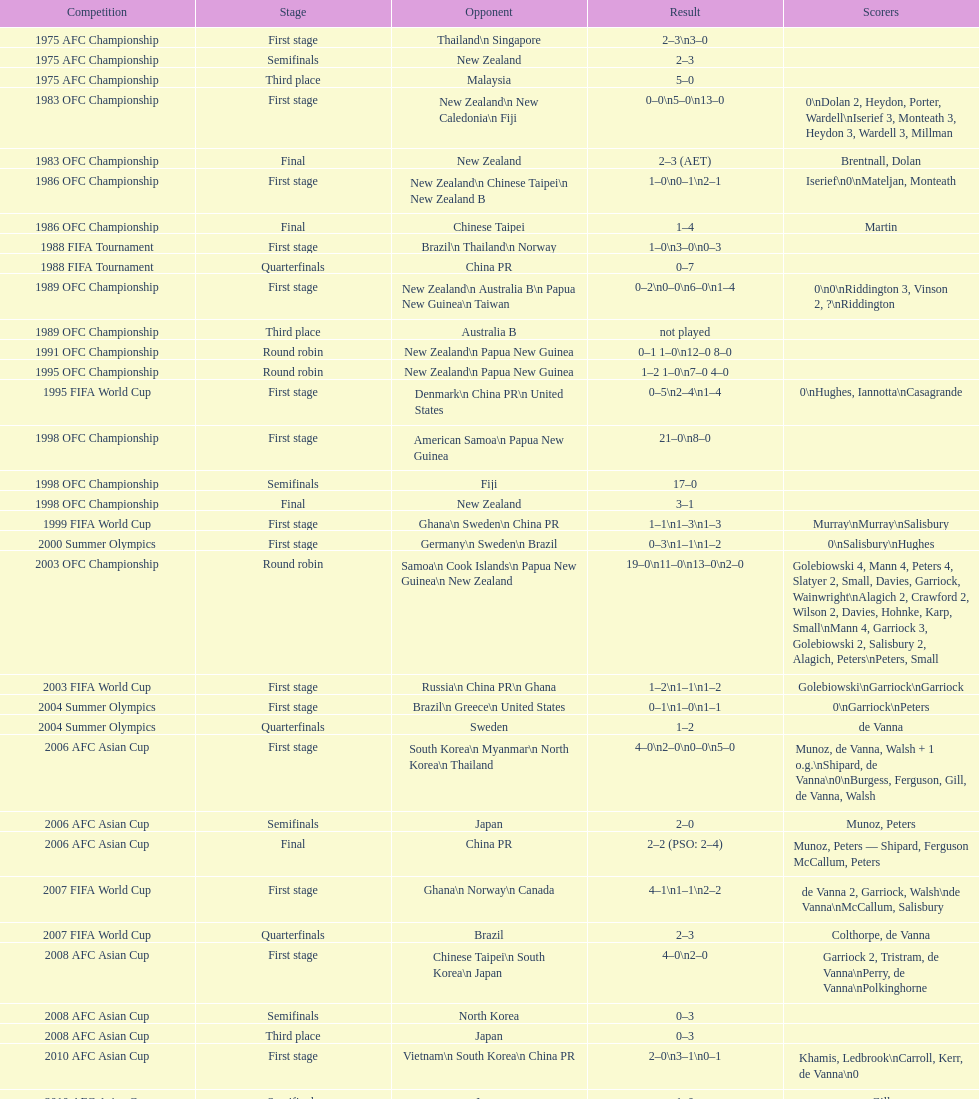What is the overall amount of contests? 21. Could you parse the entire table? {'header': ['Competition', 'Stage', 'Opponent', 'Result', 'Scorers'], 'rows': [['1975 AFC Championship', 'First stage', 'Thailand\\n\xa0Singapore', '2–3\\n3–0', ''], ['1975 AFC Championship', 'Semifinals', 'New Zealand', '2–3', ''], ['1975 AFC Championship', 'Third place', 'Malaysia', '5–0', ''], ['1983 OFC Championship', 'First stage', 'New Zealand\\n\xa0New Caledonia\\n\xa0Fiji', '0–0\\n5–0\\n13–0', '0\\nDolan 2, Heydon, Porter, Wardell\\nIserief 3, Monteath 3, Heydon 3, Wardell 3, Millman'], ['1983 OFC Championship', 'Final', 'New Zealand', '2–3 (AET)', 'Brentnall, Dolan'], ['1986 OFC Championship', 'First stage', 'New Zealand\\n\xa0Chinese Taipei\\n New Zealand B', '1–0\\n0–1\\n2–1', 'Iserief\\n0\\nMateljan, Monteath'], ['1986 OFC Championship', 'Final', 'Chinese Taipei', '1–4', 'Martin'], ['1988 FIFA Tournament', 'First stage', 'Brazil\\n\xa0Thailand\\n\xa0Norway', '1–0\\n3–0\\n0–3', ''], ['1988 FIFA Tournament', 'Quarterfinals', 'China PR', '0–7', ''], ['1989 OFC Championship', 'First stage', 'New Zealand\\n Australia B\\n\xa0Papua New Guinea\\n\xa0Taiwan', '0–2\\n0–0\\n6–0\\n1–4', '0\\n0\\nRiddington 3, Vinson 2,\xa0?\\nRiddington'], ['1989 OFC Championship', 'Third place', 'Australia B', 'not played', ''], ['1991 OFC Championship', 'Round robin', 'New Zealand\\n\xa0Papua New Guinea', '0–1 1–0\\n12–0 8–0', ''], ['1995 OFC Championship', 'Round robin', 'New Zealand\\n\xa0Papua New Guinea', '1–2 1–0\\n7–0 4–0', ''], ['1995 FIFA World Cup', 'First stage', 'Denmark\\n\xa0China PR\\n\xa0United States', '0–5\\n2–4\\n1–4', '0\\nHughes, Iannotta\\nCasagrande'], ['1998 OFC Championship', 'First stage', 'American Samoa\\n\xa0Papua New Guinea', '21–0\\n8–0', ''], ['1998 OFC Championship', 'Semifinals', 'Fiji', '17–0', ''], ['1998 OFC Championship', 'Final', 'New Zealand', '3–1', ''], ['1999 FIFA World Cup', 'First stage', 'Ghana\\n\xa0Sweden\\n\xa0China PR', '1–1\\n1–3\\n1–3', 'Murray\\nMurray\\nSalisbury'], ['2000 Summer Olympics', 'First stage', 'Germany\\n\xa0Sweden\\n\xa0Brazil', '0–3\\n1–1\\n1–2', '0\\nSalisbury\\nHughes'], ['2003 OFC Championship', 'Round robin', 'Samoa\\n\xa0Cook Islands\\n\xa0Papua New Guinea\\n\xa0New Zealand', '19–0\\n11–0\\n13–0\\n2–0', 'Golebiowski 4, Mann 4, Peters 4, Slatyer 2, Small, Davies, Garriock, Wainwright\\nAlagich 2, Crawford 2, Wilson 2, Davies, Hohnke, Karp, Small\\nMann 4, Garriock 3, Golebiowski 2, Salisbury 2, Alagich, Peters\\nPeters, Small'], ['2003 FIFA World Cup', 'First stage', 'Russia\\n\xa0China PR\\n\xa0Ghana', '1–2\\n1–1\\n1–2', 'Golebiowski\\nGarriock\\nGarriock'], ['2004 Summer Olympics', 'First stage', 'Brazil\\n\xa0Greece\\n\xa0United States', '0–1\\n1–0\\n1–1', '0\\nGarriock\\nPeters'], ['2004 Summer Olympics', 'Quarterfinals', 'Sweden', '1–2', 'de Vanna'], ['2006 AFC Asian Cup', 'First stage', 'South Korea\\n\xa0Myanmar\\n\xa0North Korea\\n\xa0Thailand', '4–0\\n2–0\\n0–0\\n5–0', 'Munoz, de Vanna, Walsh + 1 o.g.\\nShipard, de Vanna\\n0\\nBurgess, Ferguson, Gill, de Vanna, Walsh'], ['2006 AFC Asian Cup', 'Semifinals', 'Japan', '2–0', 'Munoz, Peters'], ['2006 AFC Asian Cup', 'Final', 'China PR', '2–2 (PSO: 2–4)', 'Munoz, Peters — Shipard, Ferguson McCallum, Peters'], ['2007 FIFA World Cup', 'First stage', 'Ghana\\n\xa0Norway\\n\xa0Canada', '4–1\\n1–1\\n2–2', 'de Vanna 2, Garriock, Walsh\\nde Vanna\\nMcCallum, Salisbury'], ['2007 FIFA World Cup', 'Quarterfinals', 'Brazil', '2–3', 'Colthorpe, de Vanna'], ['2008 AFC Asian Cup', 'First stage', 'Chinese Taipei\\n\xa0South Korea\\n\xa0Japan', '4–0\\n2–0', 'Garriock 2, Tristram, de Vanna\\nPerry, de Vanna\\nPolkinghorne'], ['2008 AFC Asian Cup', 'Semifinals', 'North Korea', '0–3', ''], ['2008 AFC Asian Cup', 'Third place', 'Japan', '0–3', ''], ['2010 AFC Asian Cup', 'First stage', 'Vietnam\\n\xa0South Korea\\n\xa0China PR', '2–0\\n3–1\\n0–1', 'Khamis, Ledbrook\\nCarroll, Kerr, de Vanna\\n0'], ['2010 AFC Asian Cup', 'Semifinals', 'Japan', '1–0', 'Gill'], ['2010 AFC Asian Cup', 'Final', 'North Korea', '1–1 (PSO: 5–4)', 'Kerr — PSO: Shipard, Ledbrook, Gill, Garriock, Simon'], ['2011 FIFA World Cup', 'First stage', 'Brazil\\n\xa0Equatorial Guinea\\n\xa0Norway', '0–1\\n3–2\\n2–1', '0\\nvan Egmond, Khamis, de Vanna\\nSimon 2'], ['2011 FIFA World Cup', 'Quarterfinals', 'Sweden', '1–3', 'Perry'], ['2012 Summer Olympics\\nAFC qualification', 'Final round', 'North Korea\\n\xa0Thailand\\n\xa0Japan\\n\xa0China PR\\n\xa0South Korea', '0–1\\n5–1\\n0–1\\n1–0\\n2–1', '0\\nHeyman 2, Butt, van Egmond, Simon\\n0\\nvan Egmond\\nButt, de Vanna'], ['2014 AFC Asian Cup', 'First stage', 'Japan\\n\xa0Jordan\\n\xa0Vietnam', 'TBD\\nTBD\\nTBD', '']]} 